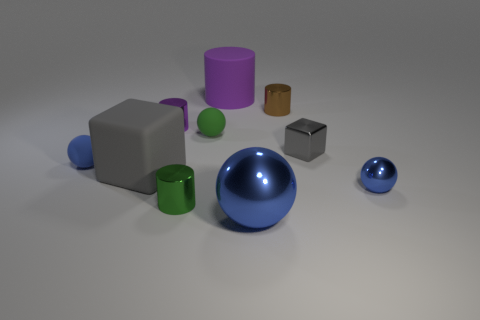How many objects are large shiny spheres or cylinders in front of the large gray thing?
Offer a terse response. 2. Are there any large gray rubber objects of the same shape as the brown object?
Ensure brevity in your answer.  No. Is the number of small green shiny cylinders that are left of the green metallic cylinder the same as the number of green matte spheres in front of the green rubber thing?
Provide a short and direct response. Yes. What number of red objects are spheres or tiny shiny objects?
Your answer should be very brief. 0. What number of blue rubber cylinders have the same size as the rubber block?
Your response must be concise. 0. What is the color of the shiny cylinder that is both left of the big purple object and behind the small green rubber sphere?
Provide a succinct answer. Purple. Are there more purple matte cylinders behind the tiny gray object than small cyan things?
Your answer should be compact. Yes. Are there any green spheres?
Your answer should be compact. Yes. Do the tiny cube and the matte cube have the same color?
Offer a terse response. Yes. How many tiny objects are either purple rubber objects or metal blocks?
Your response must be concise. 1. 